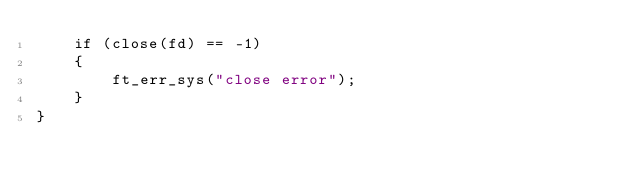<code> <loc_0><loc_0><loc_500><loc_500><_C_>	if (close(fd) == -1)
	{
		ft_err_sys("close error");
	}
}</code> 